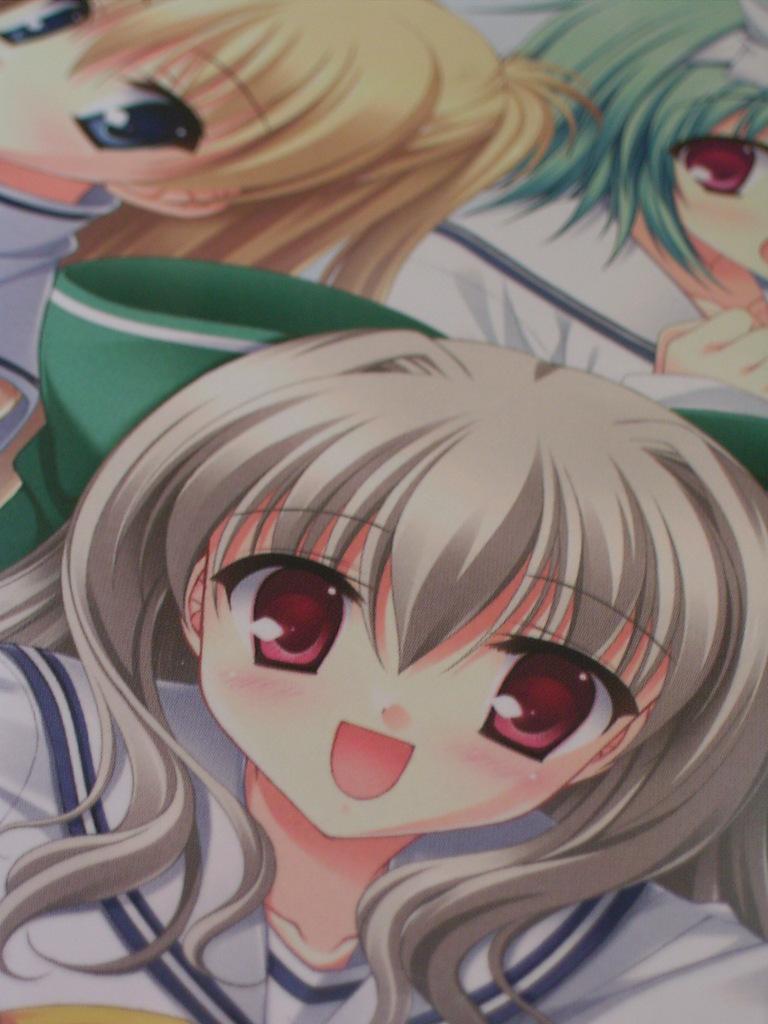In one or two sentences, can you explain what this image depicts? There are cartoons presenting in this picture. 